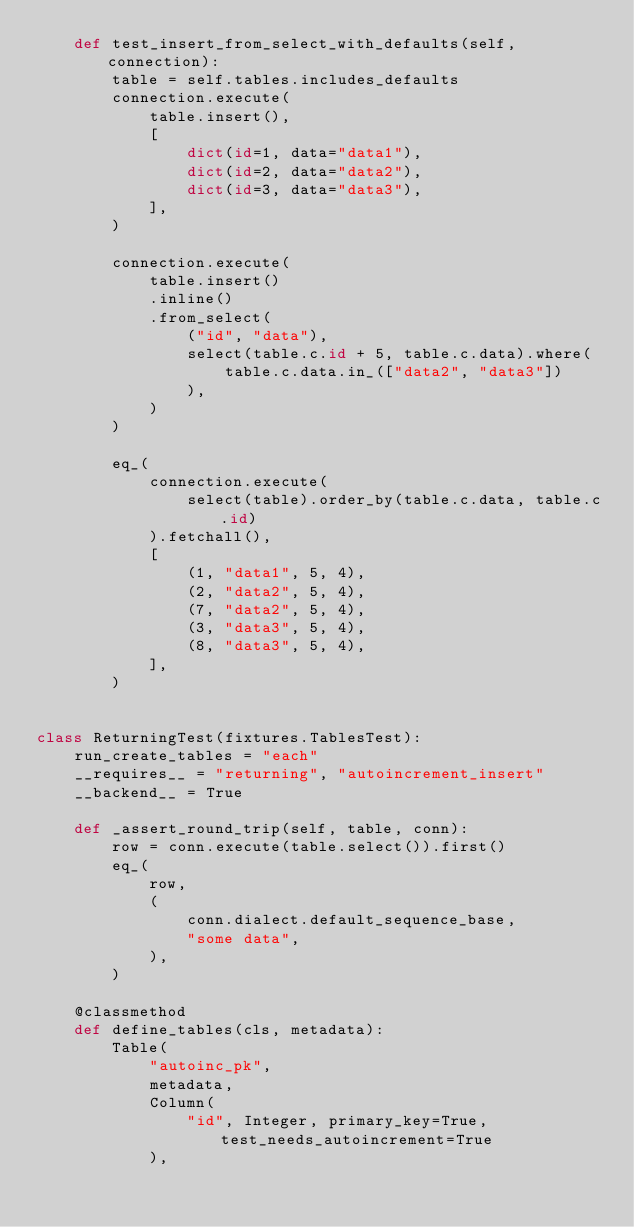<code> <loc_0><loc_0><loc_500><loc_500><_Python_>    def test_insert_from_select_with_defaults(self, connection):
        table = self.tables.includes_defaults
        connection.execute(
            table.insert(),
            [
                dict(id=1, data="data1"),
                dict(id=2, data="data2"),
                dict(id=3, data="data3"),
            ],
        )

        connection.execute(
            table.insert()
            .inline()
            .from_select(
                ("id", "data"),
                select(table.c.id + 5, table.c.data).where(
                    table.c.data.in_(["data2", "data3"])
                ),
            )
        )

        eq_(
            connection.execute(
                select(table).order_by(table.c.data, table.c.id)
            ).fetchall(),
            [
                (1, "data1", 5, 4),
                (2, "data2", 5, 4),
                (7, "data2", 5, 4),
                (3, "data3", 5, 4),
                (8, "data3", 5, 4),
            ],
        )


class ReturningTest(fixtures.TablesTest):
    run_create_tables = "each"
    __requires__ = "returning", "autoincrement_insert"
    __backend__ = True

    def _assert_round_trip(self, table, conn):
        row = conn.execute(table.select()).first()
        eq_(
            row,
            (
                conn.dialect.default_sequence_base,
                "some data",
            ),
        )

    @classmethod
    def define_tables(cls, metadata):
        Table(
            "autoinc_pk",
            metadata,
            Column(
                "id", Integer, primary_key=True, test_needs_autoincrement=True
            ),</code> 